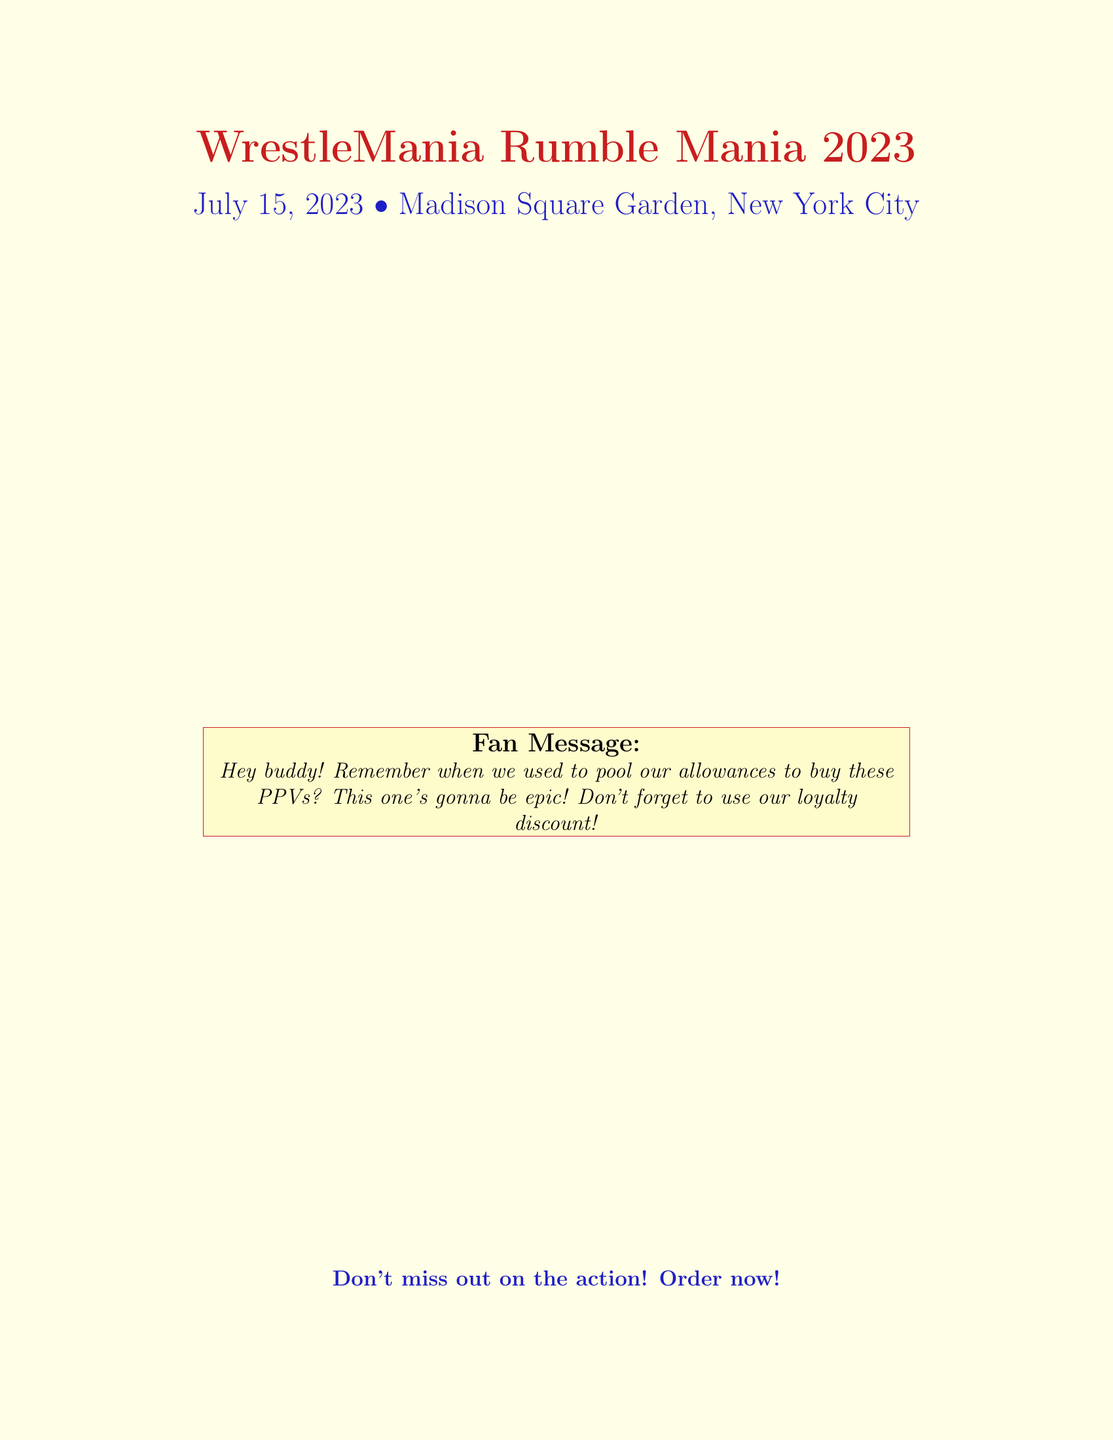What is the date of the event? The document lists the date of the event as July 15, 2023.
Answer: July 15, 2023 What is the price for the WWE Championship match? The price for the WWE Championship match is specifically stated in the document.
Answer: $29.99 What is the total before the discount? The total before applying any discount is clearly outlined as $107.93.
Answer: $107.93 What is the percentage of the loyalty discount? The loyalty discount is mentioned as a specific percentage in the document.
Answer: 15% What item has the lowest price listed? The document lists all match prices, with the Legends Appearance being the lowest.
Answer: $9.99 What is the final total after the discount? The final amount due after applying the loyalty discount is highlighted in the document.
Answer: $91.74 What is the code to use for the loyalty discount? The document provides a specific code for the loyalty discount.
Answer: LOYALFAN2023 How much is the streaming fee? The streaming fee is indicated separately in the itemized list.
Answer: $4.99 What promotional message is included for fans? The document contains a specific message directed at fans regarding the event.
Answer: Don't forget to use our loyalty discount! 